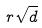<formula> <loc_0><loc_0><loc_500><loc_500>r \sqrt { d }</formula> 